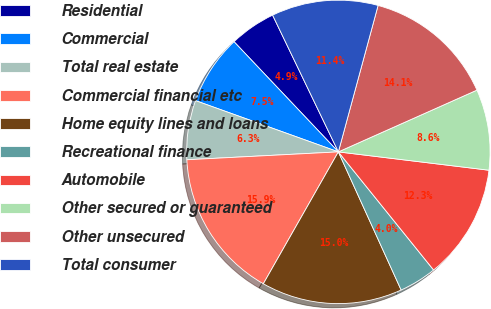Convert chart. <chart><loc_0><loc_0><loc_500><loc_500><pie_chart><fcel>Residential<fcel>Commercial<fcel>Total real estate<fcel>Commercial financial etc<fcel>Home equity lines and loans<fcel>Recreational finance<fcel>Automobile<fcel>Other secured or guaranteed<fcel>Other unsecured<fcel>Total consumer<nl><fcel>4.93%<fcel>7.45%<fcel>6.31%<fcel>15.94%<fcel>15.02%<fcel>4.01%<fcel>12.27%<fcel>8.6%<fcel>14.11%<fcel>11.35%<nl></chart> 